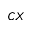<formula> <loc_0><loc_0><loc_500><loc_500>C X</formula> 